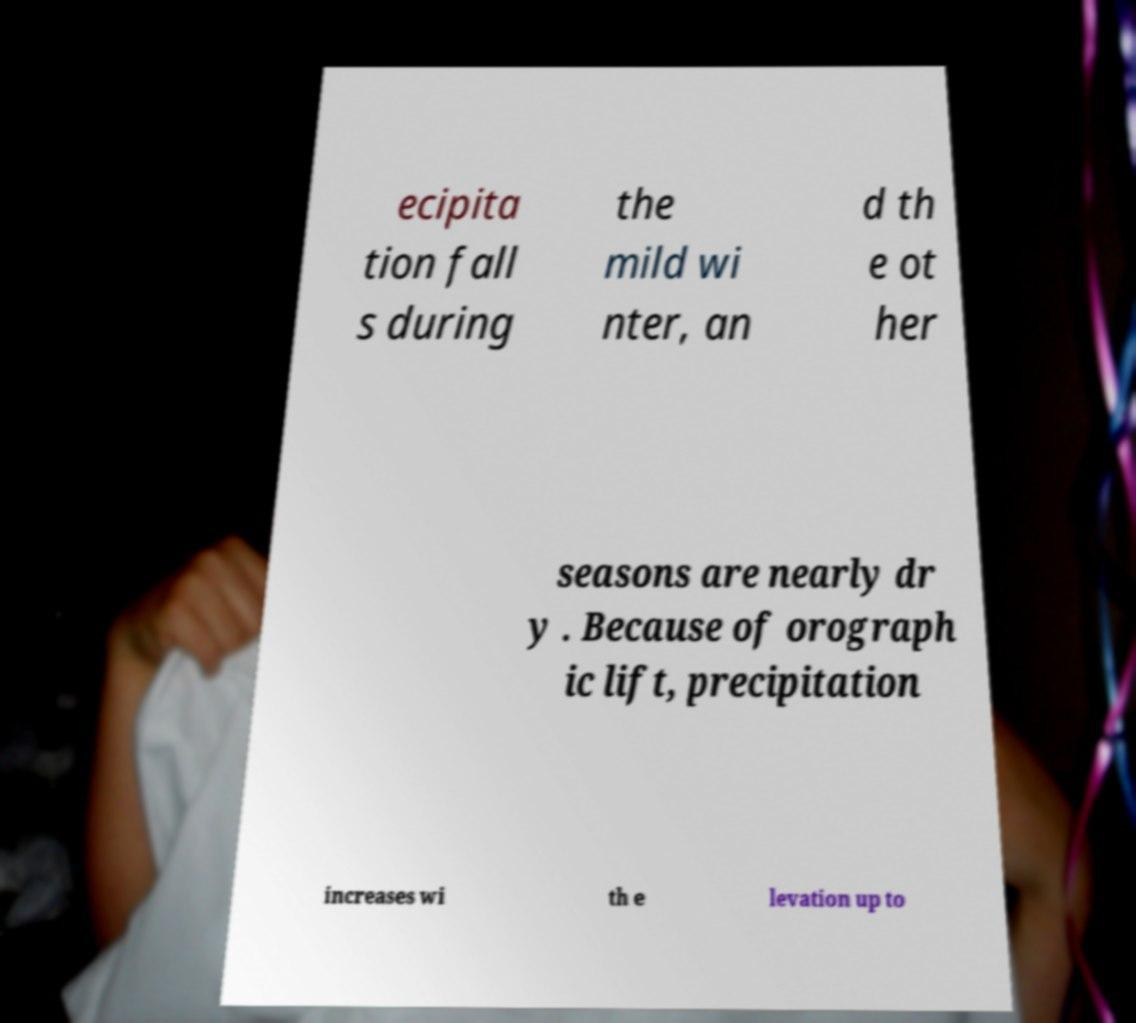Can you accurately transcribe the text from the provided image for me? ecipita tion fall s during the mild wi nter, an d th e ot her seasons are nearly dr y . Because of orograph ic lift, precipitation increases wi th e levation up to 